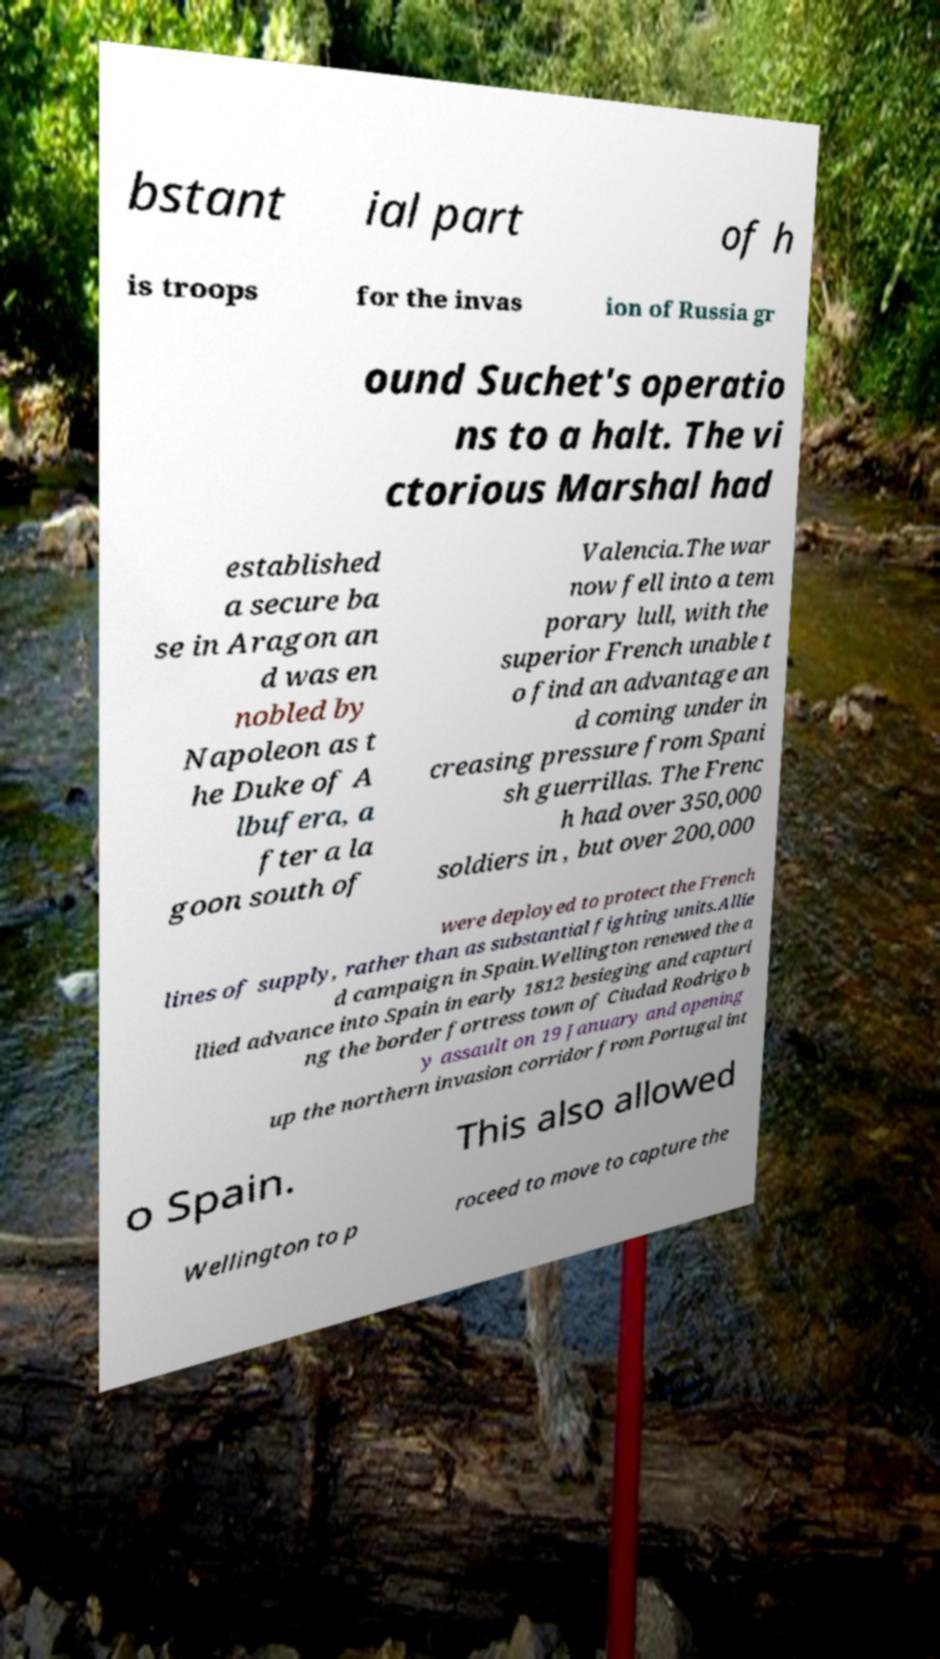I need the written content from this picture converted into text. Can you do that? bstant ial part of h is troops for the invas ion of Russia gr ound Suchet's operatio ns to a halt. The vi ctorious Marshal had established a secure ba se in Aragon an d was en nobled by Napoleon as t he Duke of A lbufera, a fter a la goon south of Valencia.The war now fell into a tem porary lull, with the superior French unable t o find an advantage an d coming under in creasing pressure from Spani sh guerrillas. The Frenc h had over 350,000 soldiers in , but over 200,000 were deployed to protect the French lines of supply, rather than as substantial fighting units.Allie d campaign in Spain.Wellington renewed the a llied advance into Spain in early 1812 besieging and capturi ng the border fortress town of Ciudad Rodrigo b y assault on 19 January and opening up the northern invasion corridor from Portugal int o Spain. This also allowed Wellington to p roceed to move to capture the 